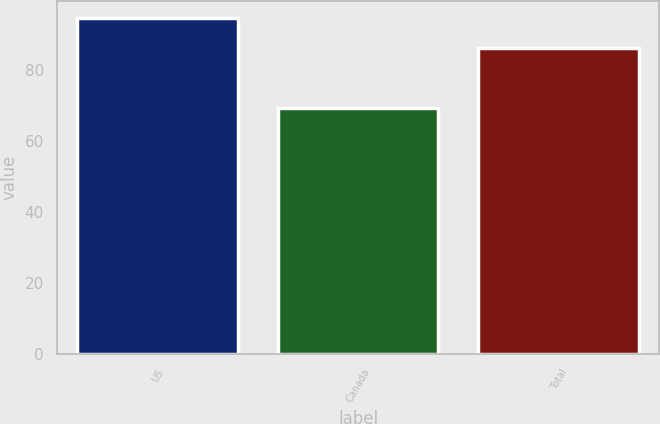Convert chart to OTSL. <chart><loc_0><loc_0><loc_500><loc_500><bar_chart><fcel>US<fcel>Canada<fcel>Total<nl><fcel>94.52<fcel>69.18<fcel>86.02<nl></chart> 